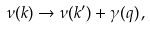<formula> <loc_0><loc_0><loc_500><loc_500>\nu ( k ) \rightarrow \nu ( k ^ { \prime } ) + \gamma ( q ) \, ,</formula> 